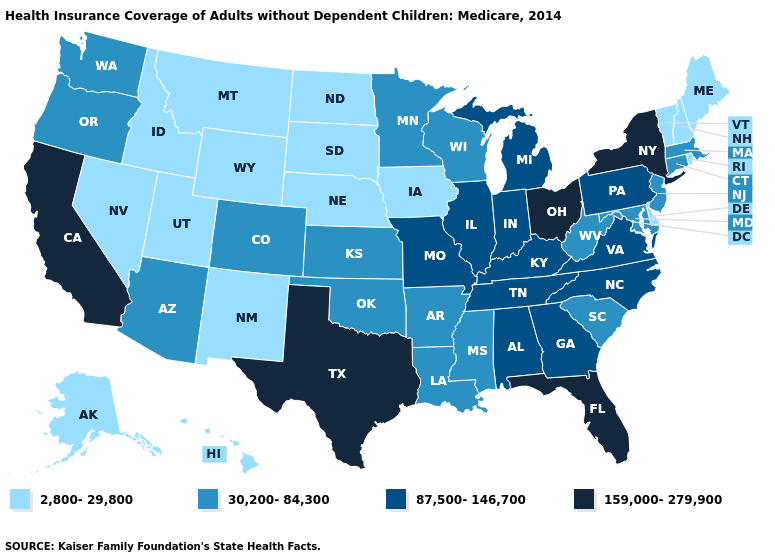Name the states that have a value in the range 2,800-29,800?
Concise answer only. Alaska, Delaware, Hawaii, Idaho, Iowa, Maine, Montana, Nebraska, Nevada, New Hampshire, New Mexico, North Dakota, Rhode Island, South Dakota, Utah, Vermont, Wyoming. What is the highest value in the USA?
Concise answer only. 159,000-279,900. What is the value of Colorado?
Write a very short answer. 30,200-84,300. What is the value of Florida?
Concise answer only. 159,000-279,900. Name the states that have a value in the range 159,000-279,900?
Be succinct. California, Florida, New York, Ohio, Texas. Which states have the lowest value in the USA?
Answer briefly. Alaska, Delaware, Hawaii, Idaho, Iowa, Maine, Montana, Nebraska, Nevada, New Hampshire, New Mexico, North Dakota, Rhode Island, South Dakota, Utah, Vermont, Wyoming. Does Delaware have the lowest value in the South?
Write a very short answer. Yes. What is the highest value in the South ?
Write a very short answer. 159,000-279,900. Does New York have the highest value in the Northeast?
Quick response, please. Yes. Among the states that border Maryland , does Delaware have the lowest value?
Be succinct. Yes. Which states have the lowest value in the West?
Answer briefly. Alaska, Hawaii, Idaho, Montana, Nevada, New Mexico, Utah, Wyoming. What is the lowest value in states that border Indiana?
Concise answer only. 87,500-146,700. What is the value of Indiana?
Quick response, please. 87,500-146,700. Name the states that have a value in the range 2,800-29,800?
Give a very brief answer. Alaska, Delaware, Hawaii, Idaho, Iowa, Maine, Montana, Nebraska, Nevada, New Hampshire, New Mexico, North Dakota, Rhode Island, South Dakota, Utah, Vermont, Wyoming. What is the value of Vermont?
Answer briefly. 2,800-29,800. 